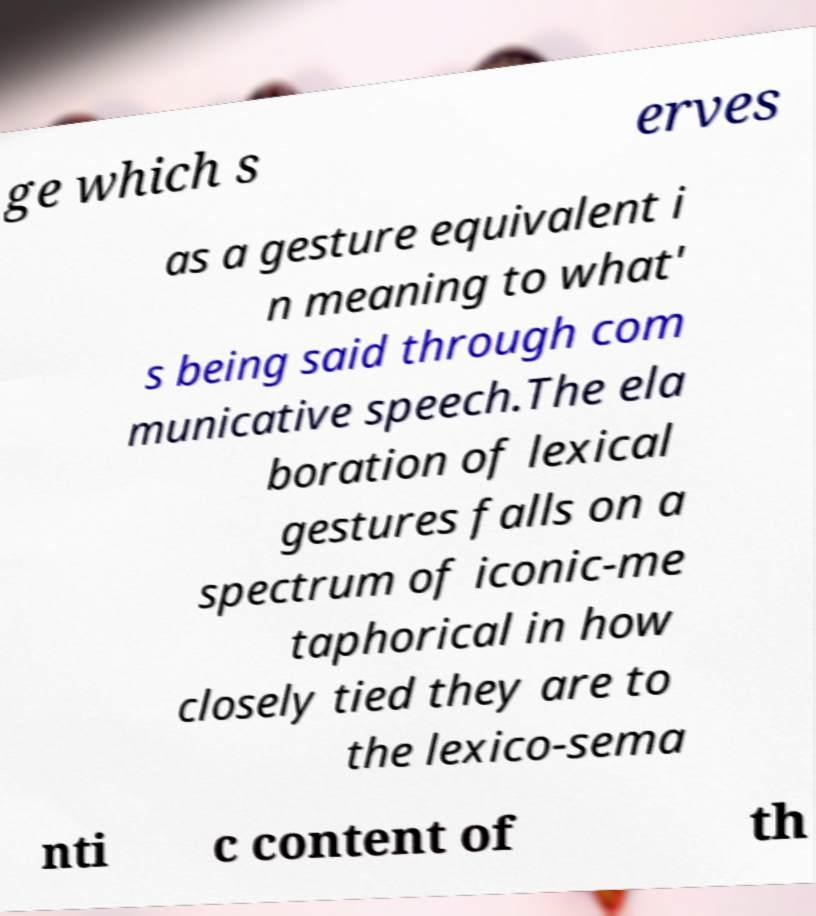For documentation purposes, I need the text within this image transcribed. Could you provide that? ge which s erves as a gesture equivalent i n meaning to what' s being said through com municative speech.The ela boration of lexical gestures falls on a spectrum of iconic-me taphorical in how closely tied they are to the lexico-sema nti c content of th 